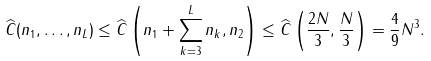Convert formula to latex. <formula><loc_0><loc_0><loc_500><loc_500>\widehat { C } ( n _ { 1 } , \dots , n _ { L } ) \leq \widehat { C } \left ( n _ { 1 } + \sum _ { k = 3 } ^ { L } n _ { k } , n _ { 2 } \right ) \leq \widehat { C } \left ( \frac { 2 N } { 3 } , \frac { N } { 3 } \right ) = \frac { 4 } { 9 } N ^ { 3 } .</formula> 